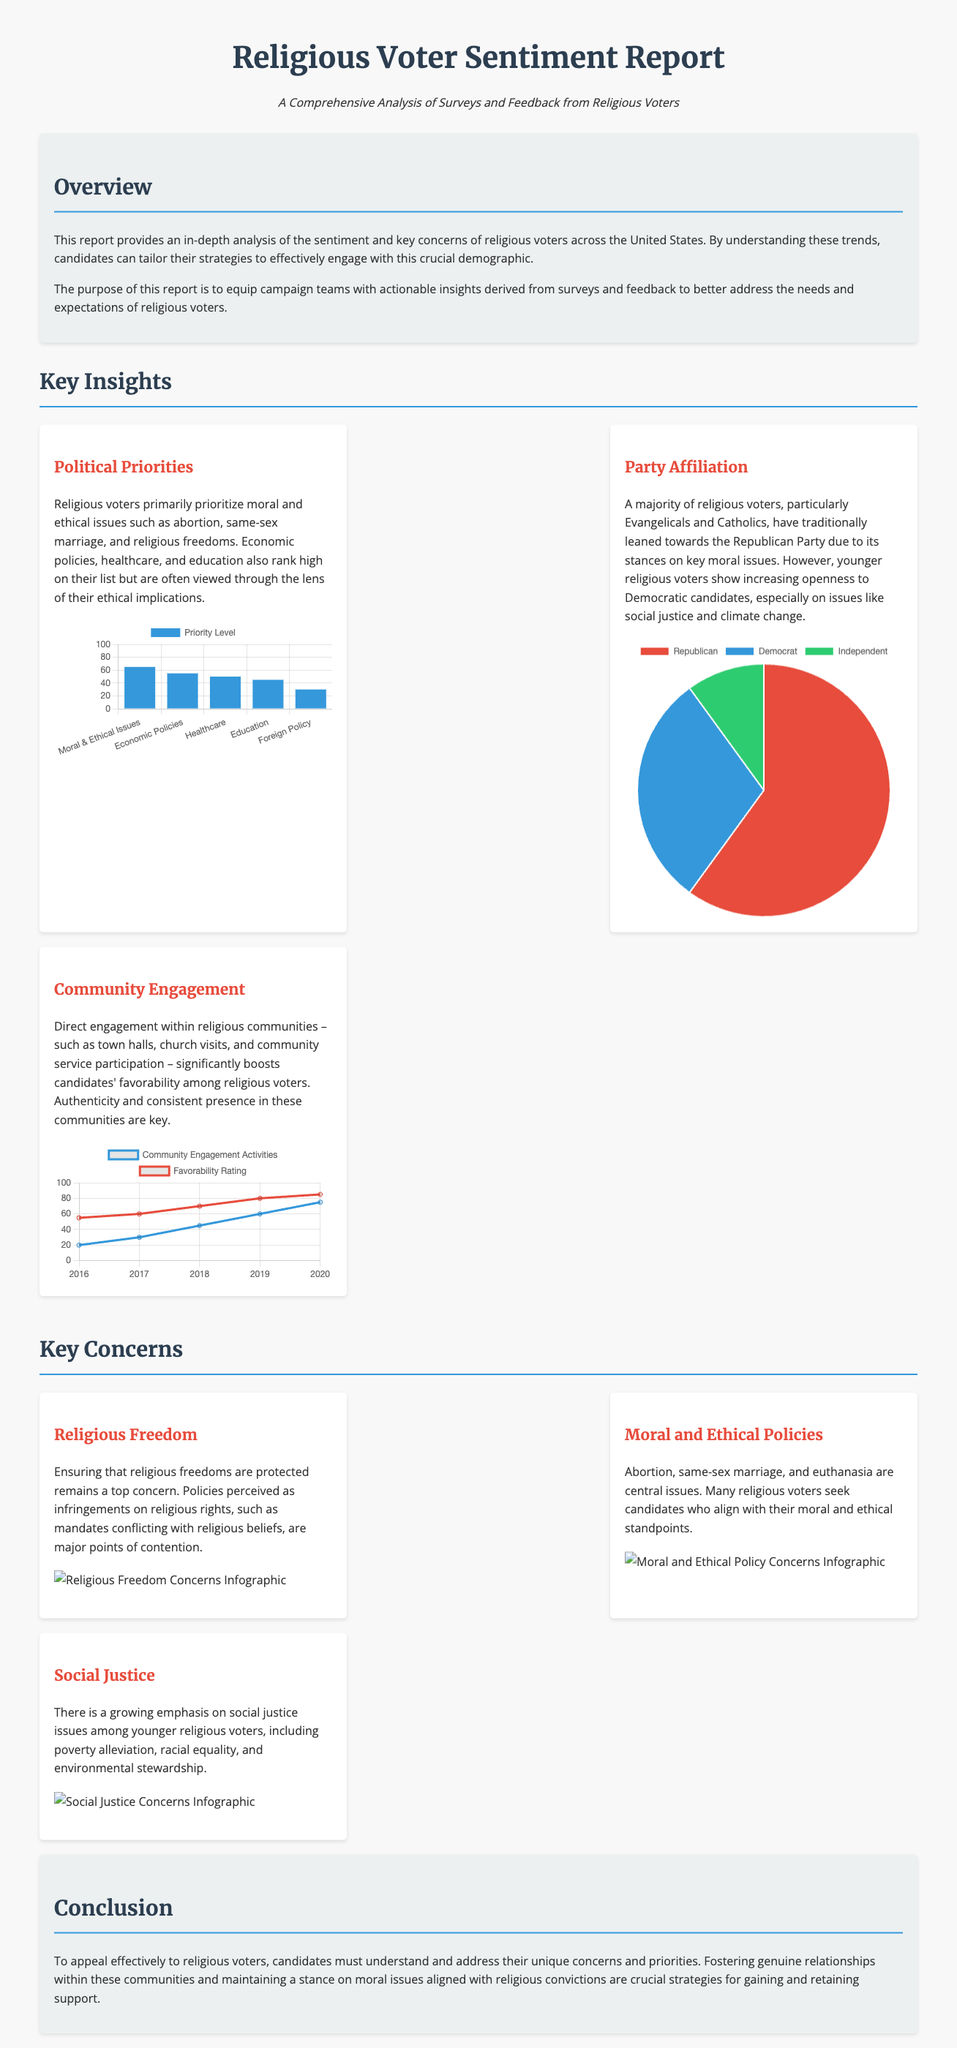What is the primary focus of religious voters? The primary focus of religious voters is mentioned in the Key Insights section, highlighting moral and ethical issues.
Answer: Moral and ethical issues Which party do a majority of religious voters traditionally lean towards? In the Key Insights section, it notes that a majority of religious voters traditionally lean towards the Republican Party.
Answer: Republican Party What is the top concern regarding religious freedoms? The top concern is related to policies perceived as infringements on religious rights, as mentioned in the Key Concerns section.
Answer: Policies perceived as infringements on religious rights Which aspect significantly boosts candidates' favorability among religious voters? The Key Insights section indicates that direct engagement within religious communities boosts candidates' favorability.
Answer: Direct engagement within religious communities What percentage of religious voters identified as Republican? The document specifies that 60% of religious voters identified as Republican in the Party Affiliation Chart.
Answer: 60% What year showed the highest favorability rating in community engagement? In the Community Engagement Chart, the highest favorability rating is noted for the year 2020.
Answer: 2020 What issues are central for many religious voters as listed in the Key Concerns section? The Key Concerns section lists abortion, same-sex marriage, and euthanasia as central issues for religious voters.
Answer: Abortion, same-sex marriage, and euthanasia How many moral and ethical issues are identified in the Political Priorities Chart? The chart shows five categories, including moral and ethical issues as a key priority.
Answer: Five What type of chart is used to represent community engagement activities? The Community Engagement Chart uses a line chart to represent community engagement activities.
Answer: Line chart 